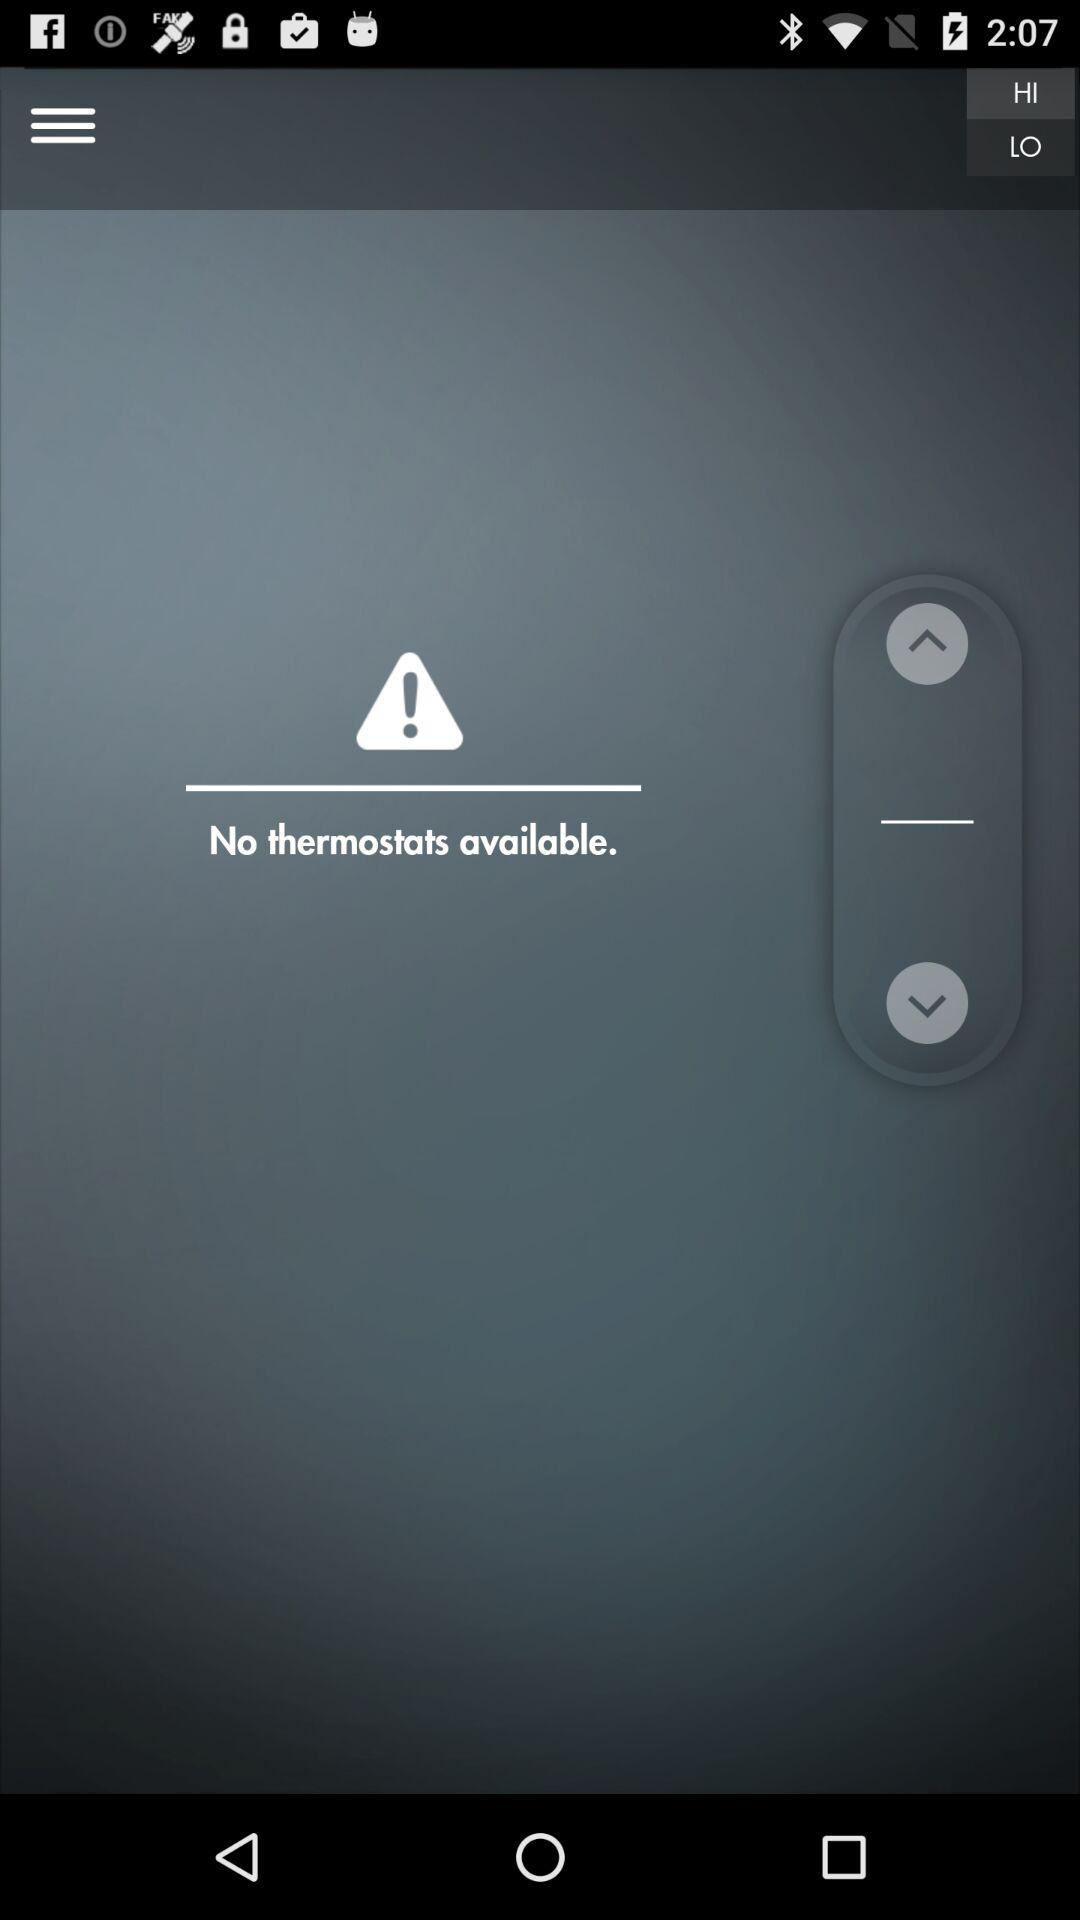How many thermostats are available?
Answer the question using a single word or phrase. 0 